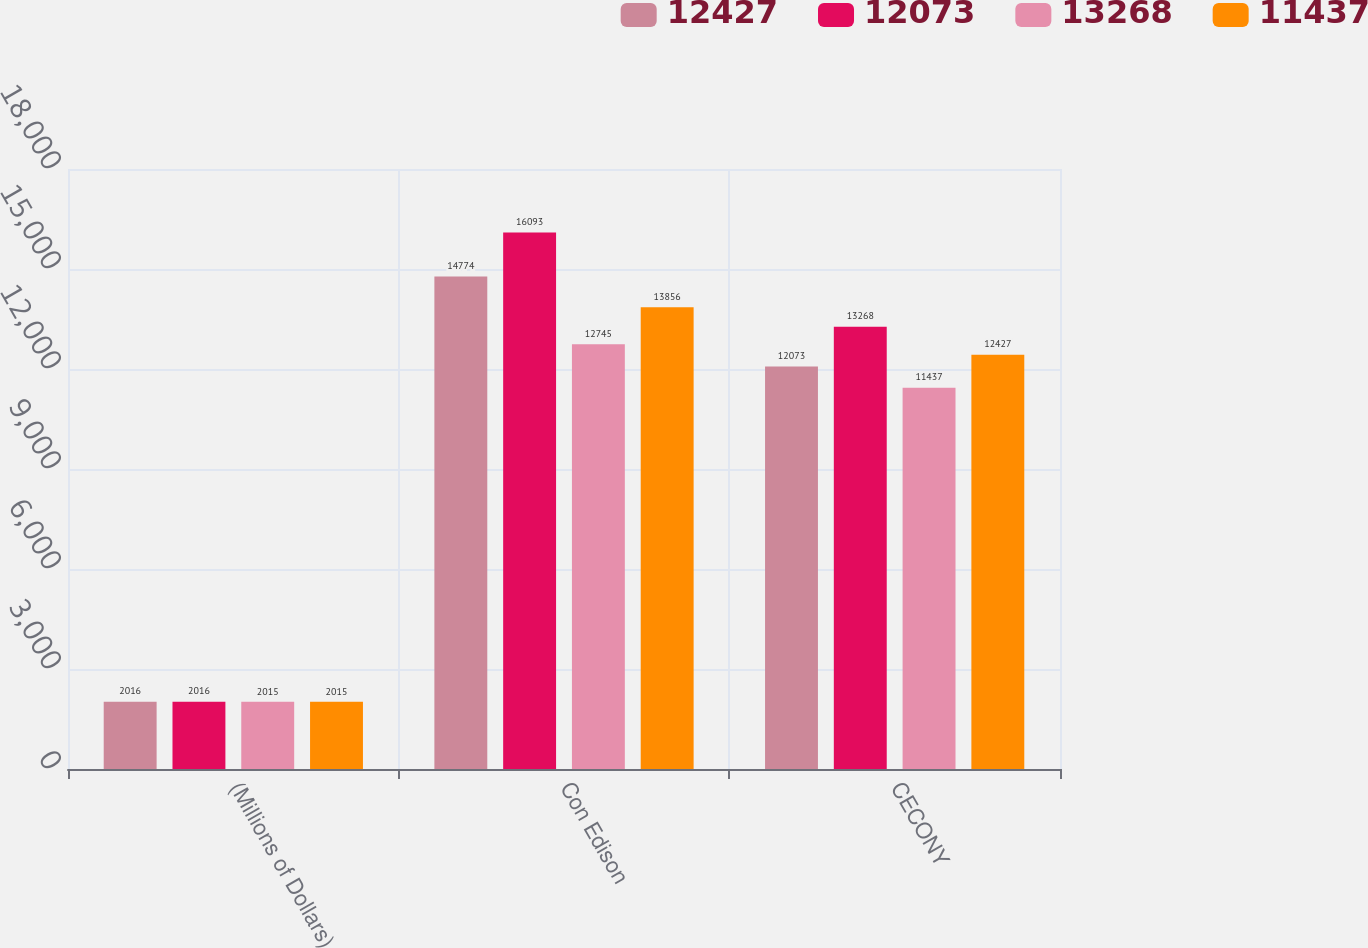<chart> <loc_0><loc_0><loc_500><loc_500><stacked_bar_chart><ecel><fcel>(Millions of Dollars)<fcel>Con Edison<fcel>CECONY<nl><fcel>12427<fcel>2016<fcel>14774<fcel>12073<nl><fcel>12073<fcel>2016<fcel>16093<fcel>13268<nl><fcel>13268<fcel>2015<fcel>12745<fcel>11437<nl><fcel>11437<fcel>2015<fcel>13856<fcel>12427<nl></chart> 